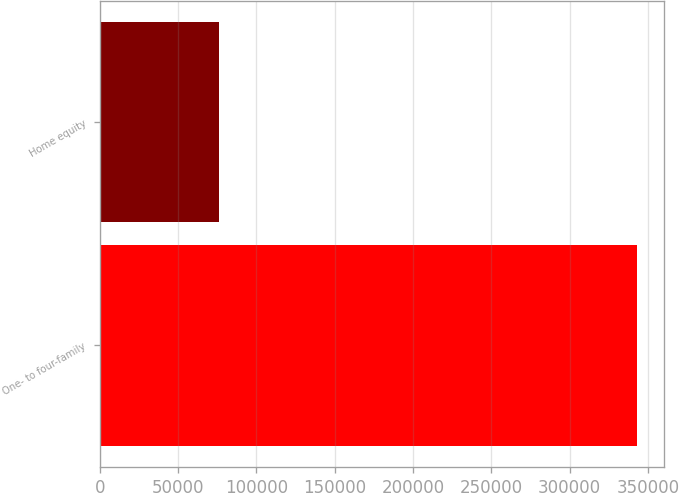Convert chart to OTSL. <chart><loc_0><loc_0><loc_500><loc_500><bar_chart><fcel>One- to four-family<fcel>Home equity<nl><fcel>342971<fcel>76282<nl></chart> 